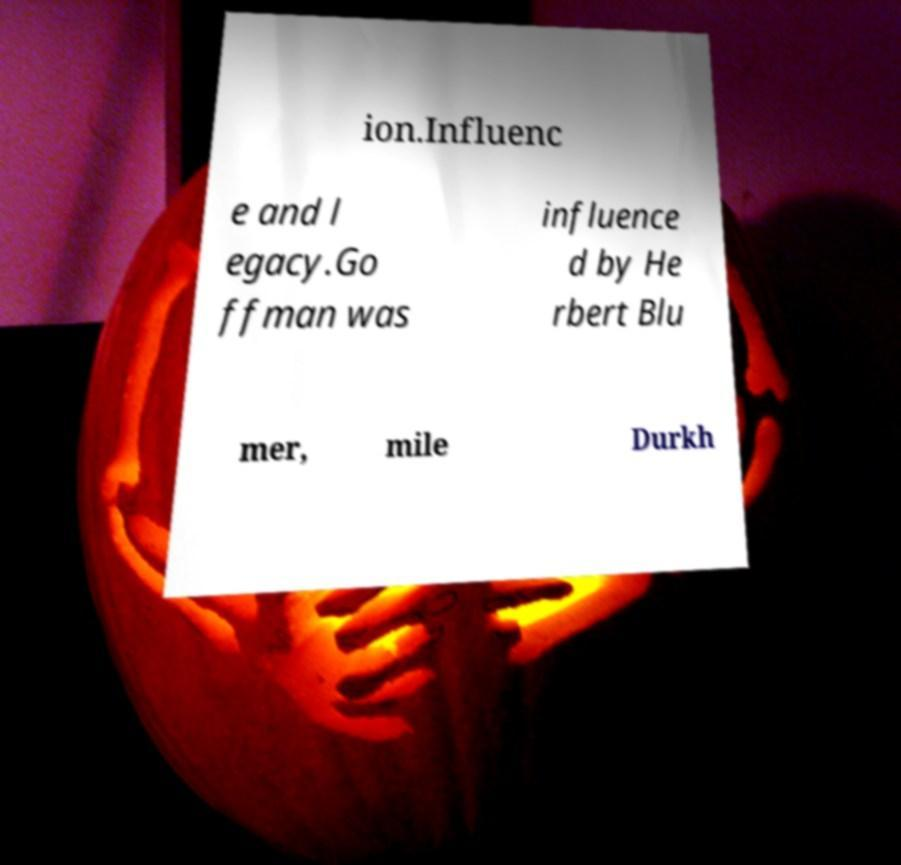Please read and relay the text visible in this image. What does it say? ion.Influenc e and l egacy.Go ffman was influence d by He rbert Blu mer, mile Durkh 